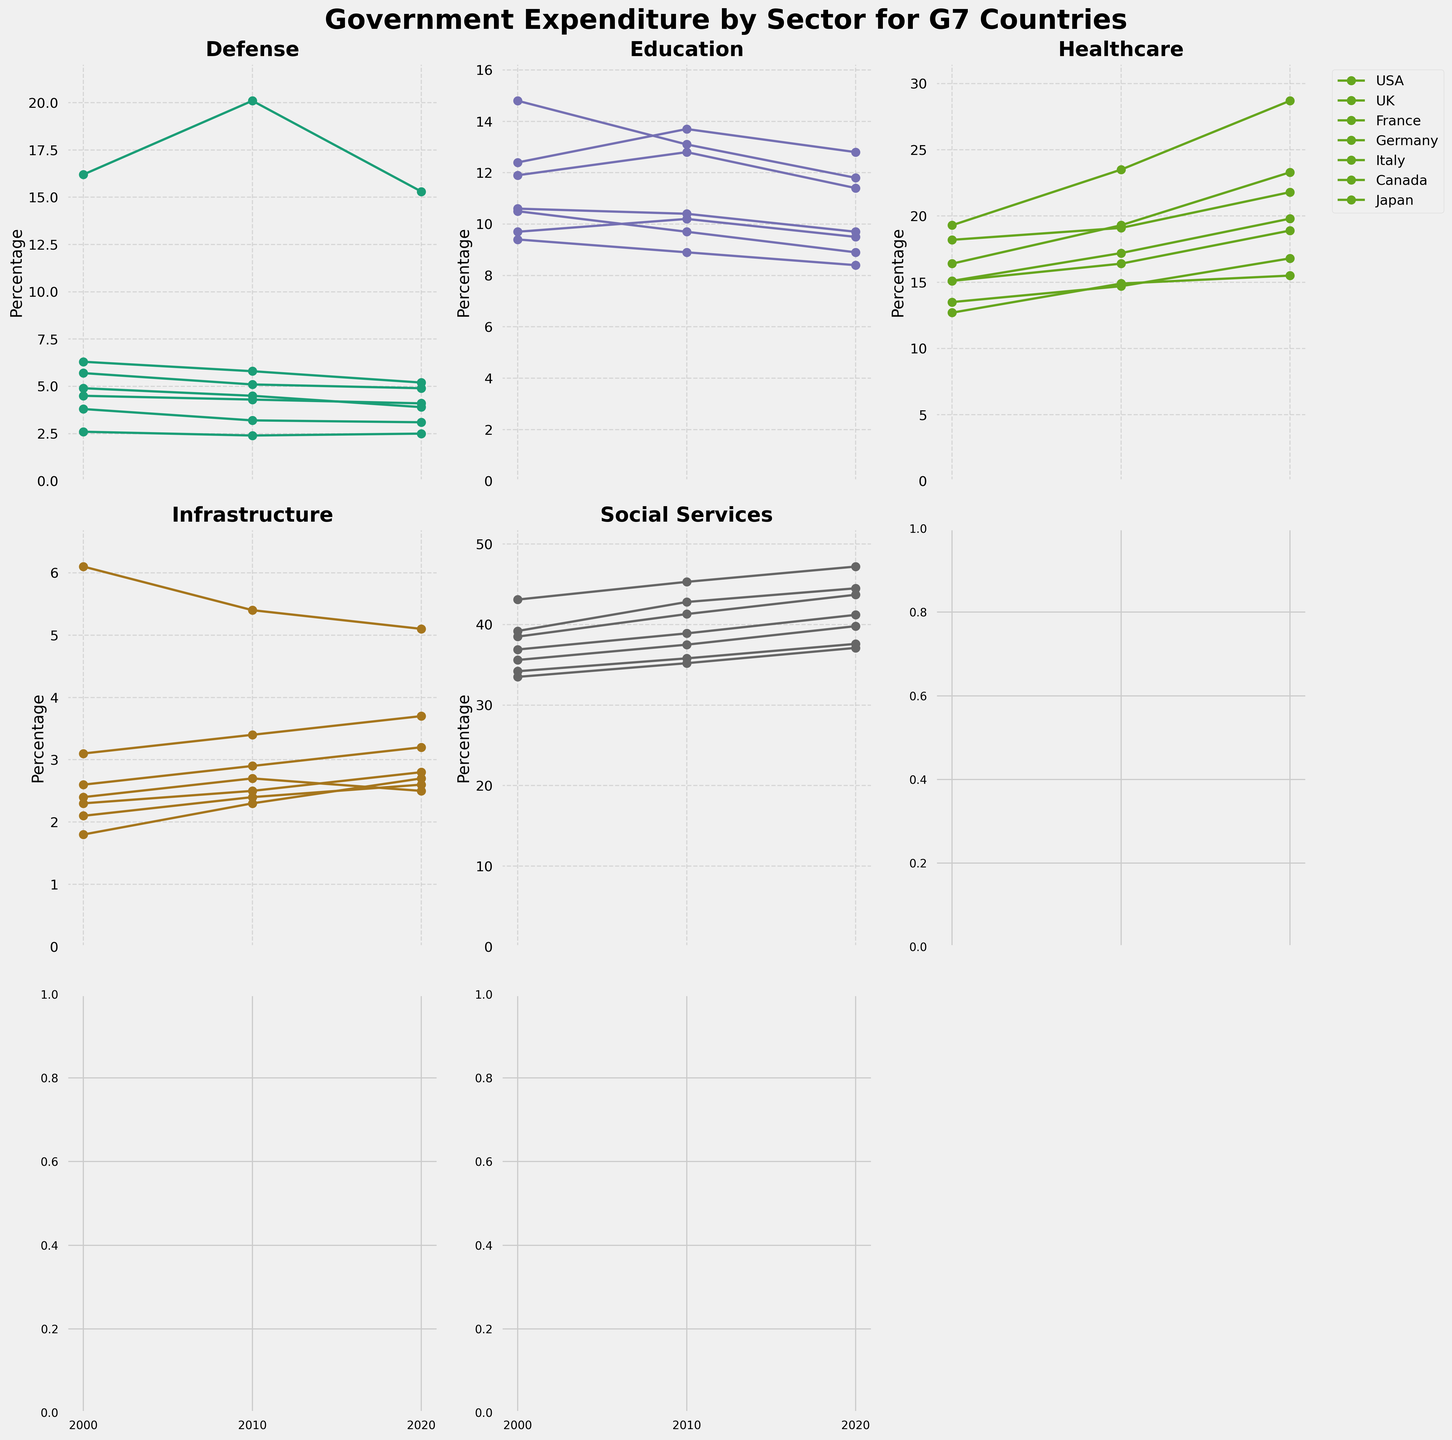What is the title of the figure? The title of the figure is always located at the top of the figure. It provides a summary of what the figure represents.
Answer: Government Expenditure by Sector for G7 Countries How does the USA’s healthcare expenditure change from 2000 to 2020? Look at the grid on healthcare expenditure and focus on the line representing the USA. Note the values at 2000 and 2020 and observe the upward or downward trend.
Answer: It increases from 19.3% in 2000 to 28.7% in 2020 Which sector has the highest expenditure in Germany in 2020? Go to the subplot for Germany and check all expenditure values for each sector in 2020. Identify the highest value among them.
Answer: Social Services Which country had the maximum increase in defense spending between 2000 and 2010? For each country, calculate the difference in defense expenditure between 2000 and 2010. Compare these differences to find the maximum increase.
Answer: USA [20.1% - 16.2% = 3.9%] What trend can be observed in Japan’s infrastructure spending from 2000 to 2020? Focus on the subplot related to Infrastructure expenditure. Look at the line corresponding to Japan and observe the pattern it follows between the years 2000, 2010, and 2020.
Answer: It fluctuates, decreasing from 6.1% in 2000 to 5.4% in 2010, and then slightly decreasing to 5.1% in 2020 Which country had a consistent decrease in education spending from 2000 to 2020? Examine each country’s education spending data points over the years 2000, 2010, and 2020, looking for a continuously descending pattern.
Answer: Italy What are the three sectors with the highest expenditure in the UK in 2010? On the UK subplot, compare the 2010 data points for each sector and identify the three highest values.
Answer: Social Services, Healthcare, Education What was the change in the total expenditure for Social Services for all G7 countries combined from 2010 to 2020? Sum the Social Services expenditure for all G7 countries in 2010 and 2020, then find the difference between these sums. (35.2+37.5+42.8+45.3+41.3+38.9+35.8 for 2010 and so on)
Answer: 272.1% to 291.1%, so the increase is 19% Between which years did Canada see the most significant rise in healthcare spending? Look at Canada's healthcare expenditure in the respective subplot for the years 2000, 2010, and 2020. Determine the years between which the most notable increase occurred.
Answer: Between 2010 and 2020 Is there any country whose defense spending never increased over the years? Check each country’s defense expenditure data points over the years 2000, 2010, and 2020 to see if there is no increase between any two consecutive years.
Answer: Japan 